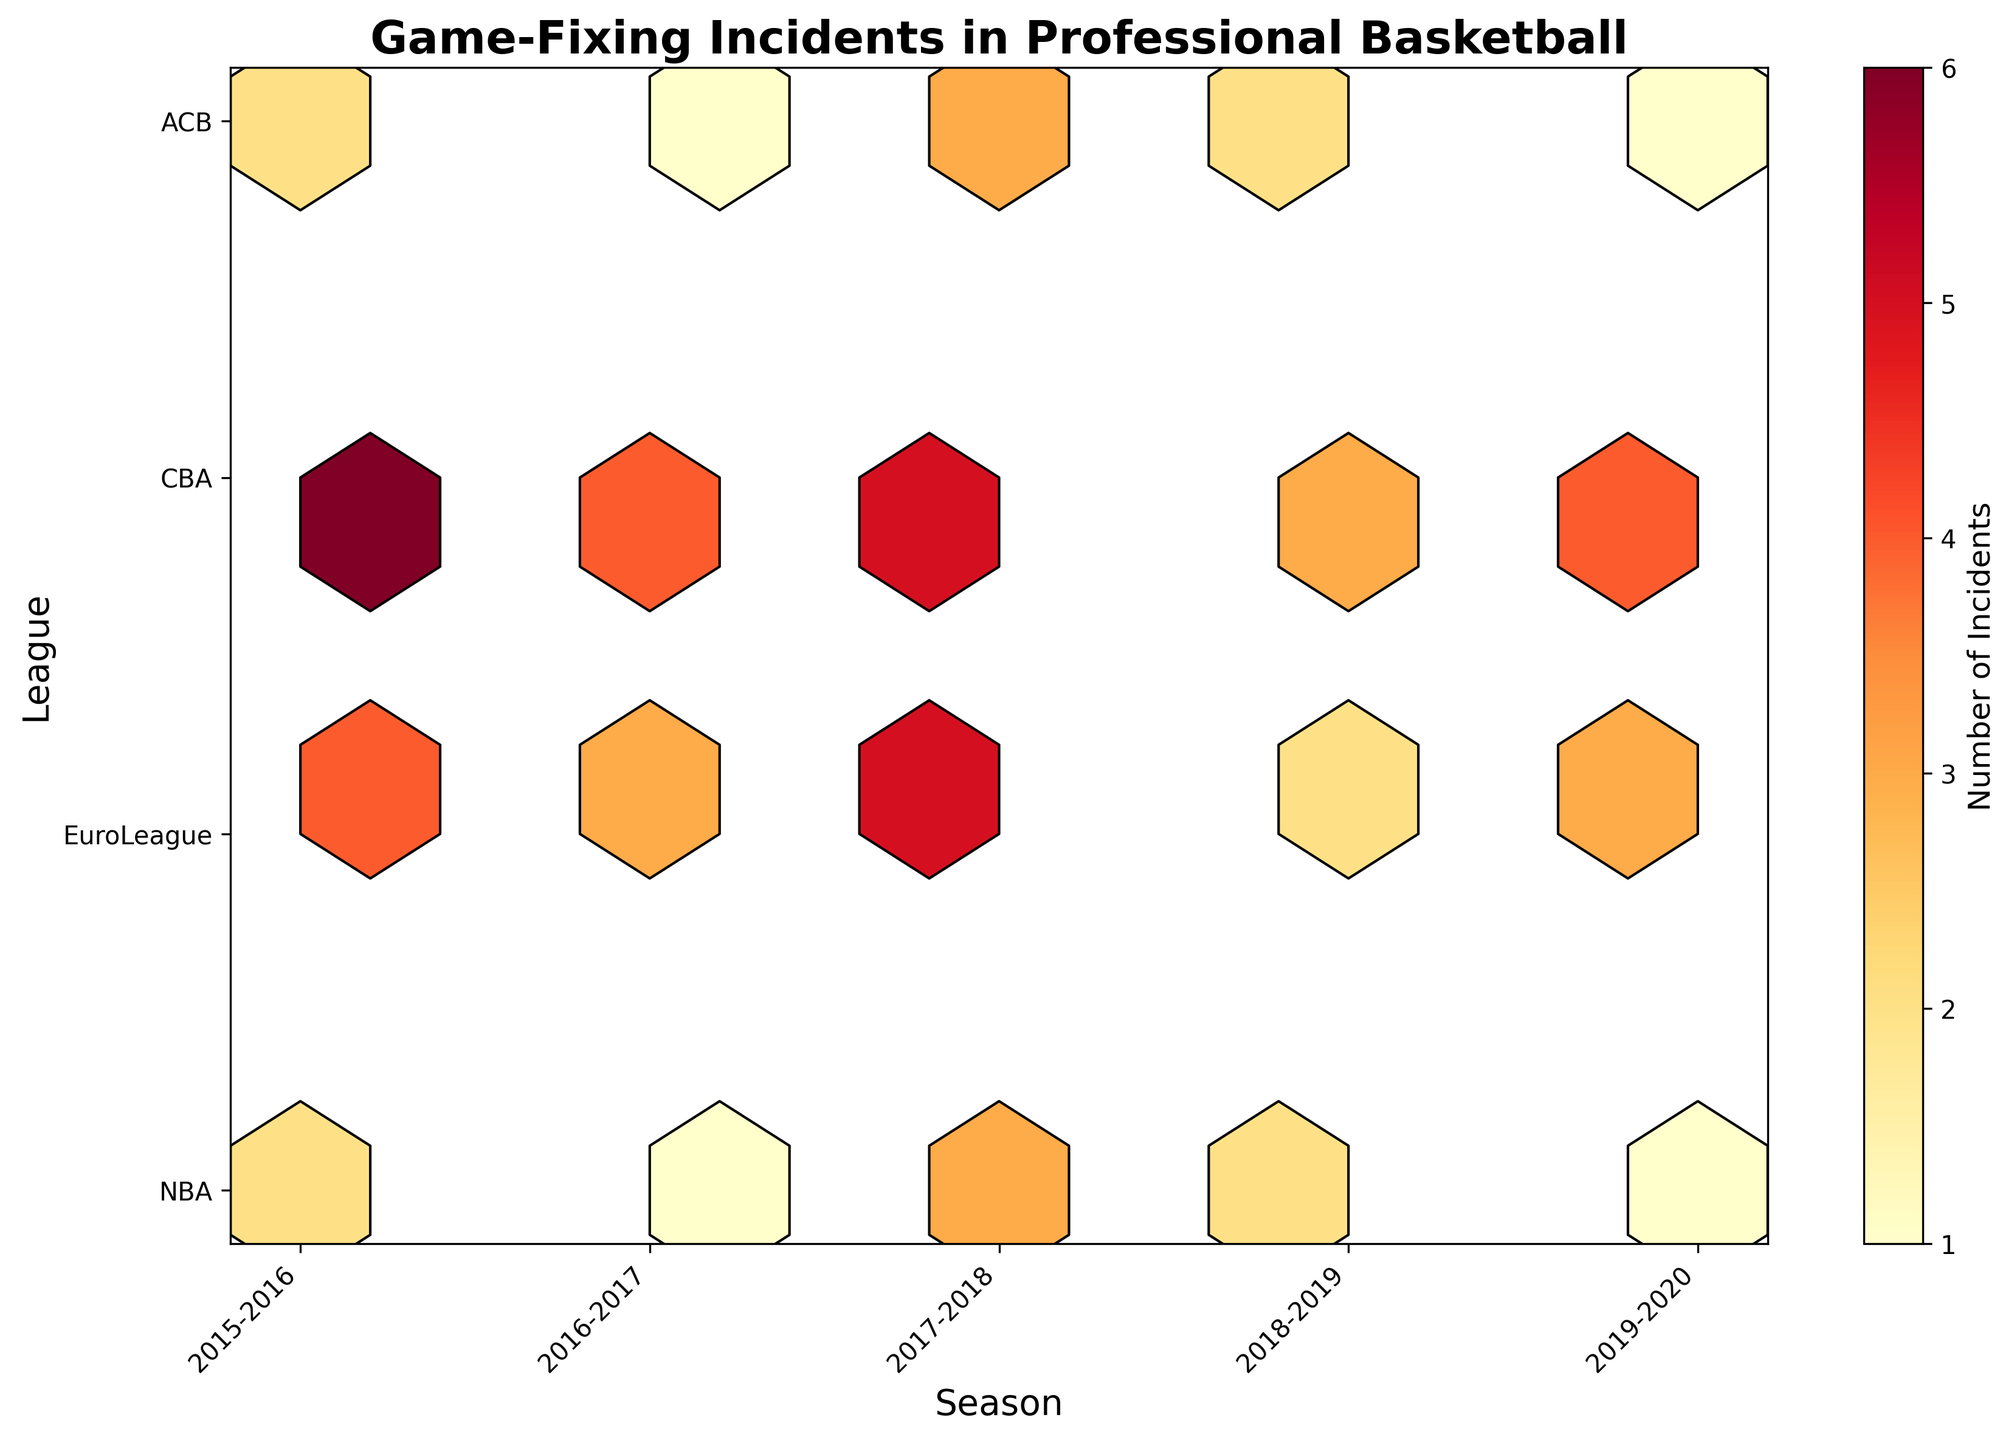What is the title of the figure? The title is located at the top of the figure usually in a large and bold font which helps to summarize the content and purpose of the visualization.
Answer: Game-Fixing Incidents in Professional Basketball What is depicted on the x-axis of the plot? The x-axis usually runs horizontally across the bottom of the figure and contains categories or numerical ranges pertinent to the data. In this case, the x-axis labels align with the different seasons represented in the visualization.
Answer: Seasons How many leagues are compared in this figure? The y-axis typically represents the categories being compared. By counting the distinct labels on the y-axis, we can determine the number of different leagues depicted in the plot.
Answer: 4 Which season in the EuroLeague had the highest number of game-fixing incidents? This requires examining the cells on the figure's grid corresponding to each season for the EuroLeague. The color intensity and value in the color bar will indicate the number of incidents.
Answer: 2017-2018 Comparing the NBA and EuroLeague, which league had more game-fixing incidents during the 2018-2019 season? Check the corresponding cells for both leagues and season in question and compare the intensity (or values if displayed) of those cells.
Answer: NBA Across all leagues, which season showed the peak number of game-fixing incidents? Here we need to identify which cell (regardless of league) shows the highest intensity or value color, typically found by scanning the entire hexbin plot.
Answer: 2017-2018 Which league experienced the highest frequency of game-fixing incidents overall? By considering the overall distribution of data points and their intensities for each league, we can determine which had the most frequent game-fixing events across all seasons.
Answer: CBA Did the ACB league experience any seasons with zero game-fixing incidents? By inspecting the ACB league's cells across all seasons, one can note any missing or uncolored segments which would indicate zero incidents.
Answer: No When did the CBA league have the fewest game-fixing incidents? Comparing all the cells for the CBA league, it can be determined which season has the lightest color intensity or the lowest number of recorded incidents.
Answer: 2018-2019 Which season had the most evenly distributed incidents across all leagues? Examining the plot for a season where the color or incident count appears consistent across all leagues suggests even distribution. The color variance would be minimal.
Answer: 2018-2019 